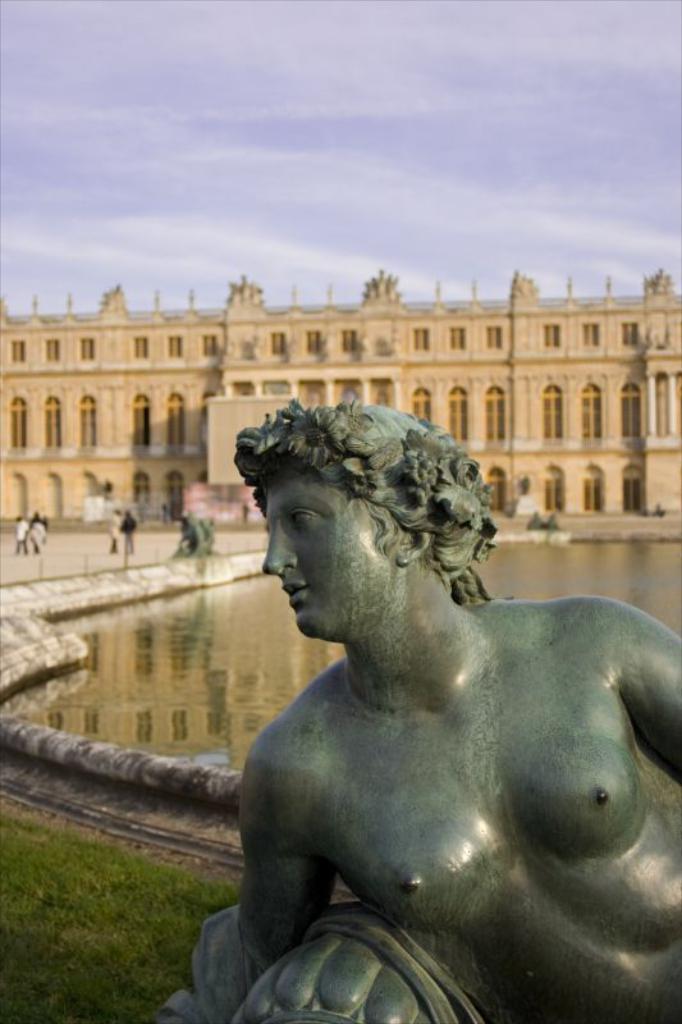Describe this image in one or two sentences. In this picture we can see a statue here, in the background there is a building, we can see some people standing here, we can see water here, there is the sky at the top of the picture. 